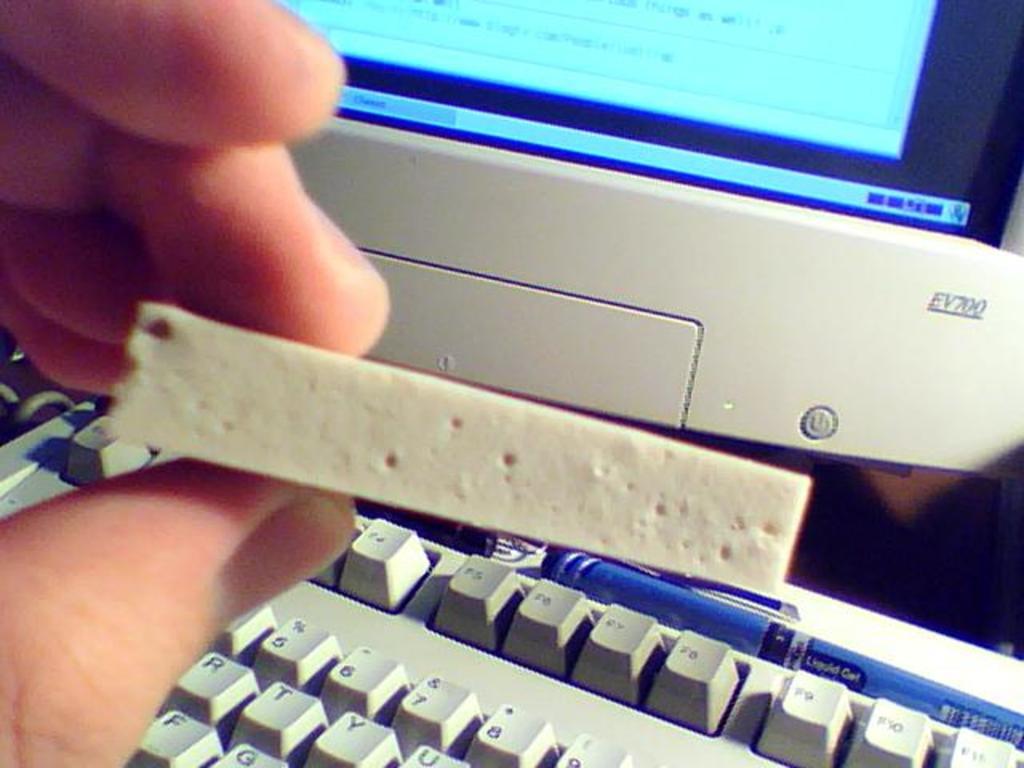What letter is to the left of y?
Make the answer very short. T. 